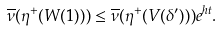Convert formula to latex. <formula><loc_0><loc_0><loc_500><loc_500>\overline { \nu } ( \eta ^ { + } ( W ( 1 ) ) ) \leq \overline { \nu } ( \eta ^ { + } ( V ( \delta ^ { \prime } ) ) ) e ^ { h t } .</formula> 